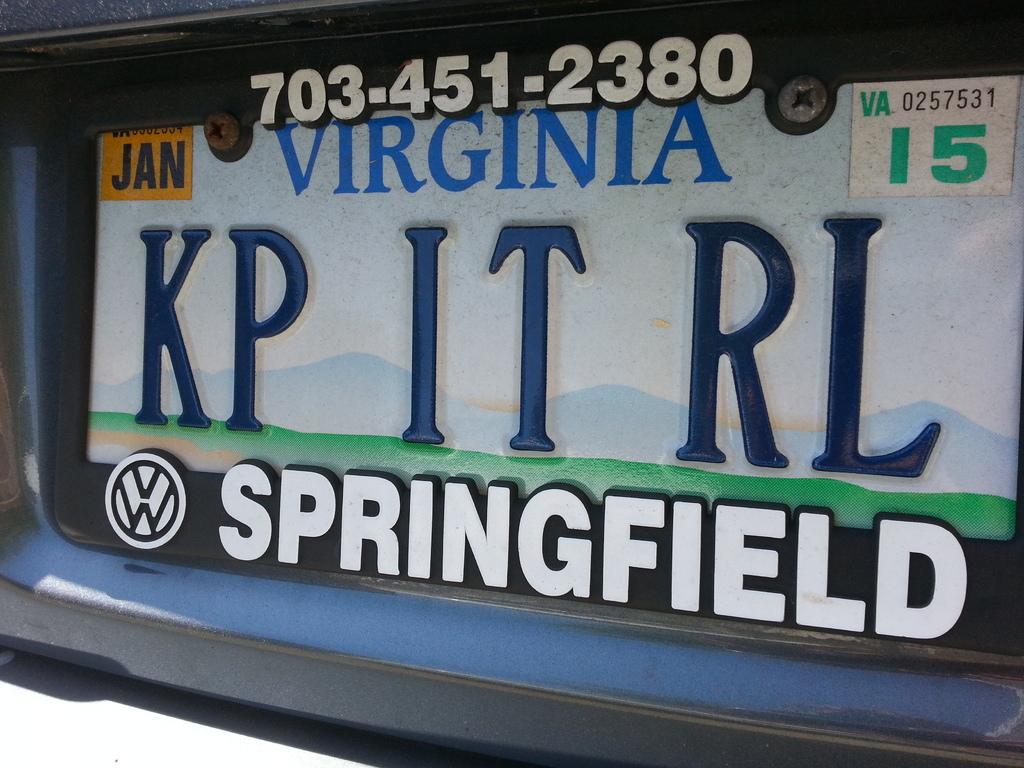What state is this license plate from?
Your answer should be compact. Virginia. The telephone number for springfield is?
Provide a succinct answer. 703-451-2380. 